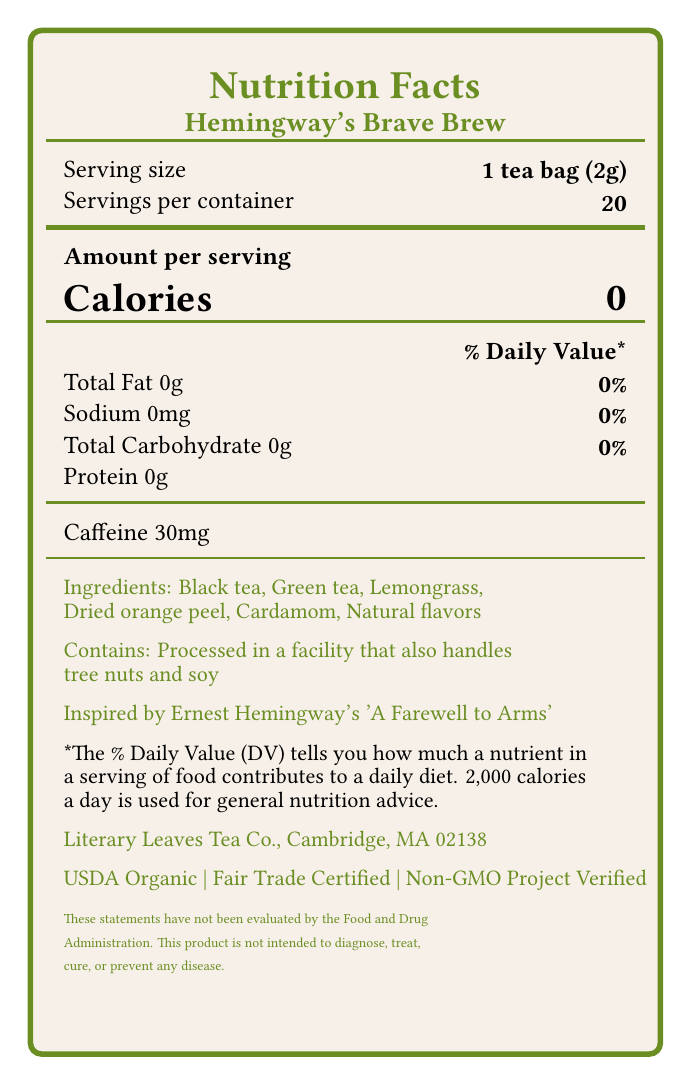what is the serving size for Hemmingway's Brave Brew? The serving size is explicitly mentioned in the document as "1 tea bag (2g)".
Answer: 1 tea bag (2g) how many servings are in one container? The number of servings per container is specified as 20 in the document.
Answer: 20 how many calories are in one serving? The number of calories per serving is listed as 0 in the document.
Answer: 0 what is the caffeine content per serving? The document states that the caffeine content per serving is 30 mg.
Answer: 30 mg what allergens are handled in the facility processing this tea? The allergen information note says it is processed in a facility that handles tree nuts and soy.
Answer: Tree nuts and soy what are the ingredients in Hemingway's Brave Brew tea blend? The ingredients are listed in the document.
Answer: Black tea, Green tea, Lemongrass, Dried orange peel, Cardamom, Natural flavors what literary work inspired this tea blend? The document specifies that the blend is inspired by "A Farewell to Arms" by Ernest Hemingway.
Answer: A Farewell to Arms by Ernest Hemingway who is the manufacturer of this tea blend? The manufacturer's information is clearly listed in the document.
Answer: Literary Leaves Tea Co., Cambridge, MA 02138 what certifications does Hemingway's Brave Brew have? A. USDA Organic B. Fair Trade Certified C. Non-GMO Project Verified D. All of the above The document lists all three certifications: USDA Organic, Fair Trade Certified, and Non-GMO Project Verified.
Answer: D. All of the above which of the following is NOT listed as a health benefit of the tea? A. Rich in antioxidants B. May improve focus and alertness C. Good for digestive health D. Supports cardiovascular health The listed health benefits include "Rich in antioxidants", "May improve focus and alertness", and "Supports cardiovascular health". "Good for digestive health" is not mentioned.
Answer: C. Good for digestive health can this tea be stored in direct sunlight? The storage instructions advise keeping the tea in a cool, dry place away from direct sunlight.
Answer: No is this product free of calories? The document indicates that there are 0 calories per serving.
Answer: Yes does the document claim this tea can diagnose diseases? The disclaimer states that the product is not intended to diagnose, treat, cure, or prevent any disease.
Answer: No summarize the main idea of the Nutrition Facts label. The summary includes all key points from the document, covering nutritional values, ingredients, manufacturer information, storage instructions, and the literary inspiration behind the tea.
Answer: The label provides detailed nutritional information, certifications, ingredients, allergens, health benefits, and storage instructions for Hemingway's Brave Brew tea, which is inspired by Ernest Hemingway's "A Farewell to Arms". The tea is zero-calorie, contains 30 mg of caffeine per serving, and is manufactured by Literary Leaves Tea Co. in Cambridge, MA. It boasts certifications such as USDA Organic, Fair Trade Certified, and Non-GMO Project Verified. how much protein is in one serving of the tea? The document only mentions "0g" for protein content and does not provide detailed nutritional breakdown beyond that specification.
Answer: Not enough information 